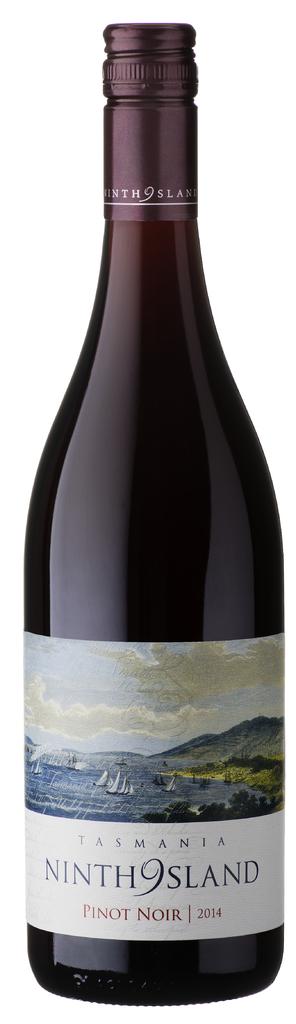When was this wine made?
Your answer should be compact. 2014. Name this drink?
Make the answer very short. Ninth9island. 